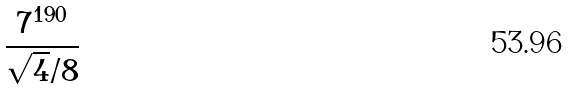<formula> <loc_0><loc_0><loc_500><loc_500>\frac { 7 ^ { 1 9 0 } } { \sqrt { 4 } / 8 }</formula> 